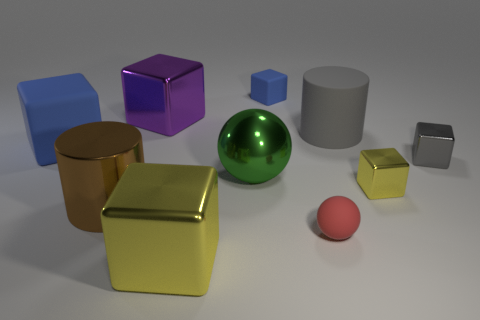Subtract all purple blocks. How many blocks are left? 5 Subtract all brown cylinders. How many cylinders are left? 1 Subtract 1 balls. How many balls are left? 1 Subtract all red spheres. How many blue blocks are left? 2 Subtract all cylinders. How many objects are left? 8 Add 6 big gray cylinders. How many big gray cylinders exist? 7 Subtract 0 purple balls. How many objects are left? 10 Subtract all yellow balls. Subtract all blue blocks. How many balls are left? 2 Subtract all tiny green matte cubes. Subtract all brown metal cylinders. How many objects are left? 9 Add 8 small red objects. How many small red objects are left? 9 